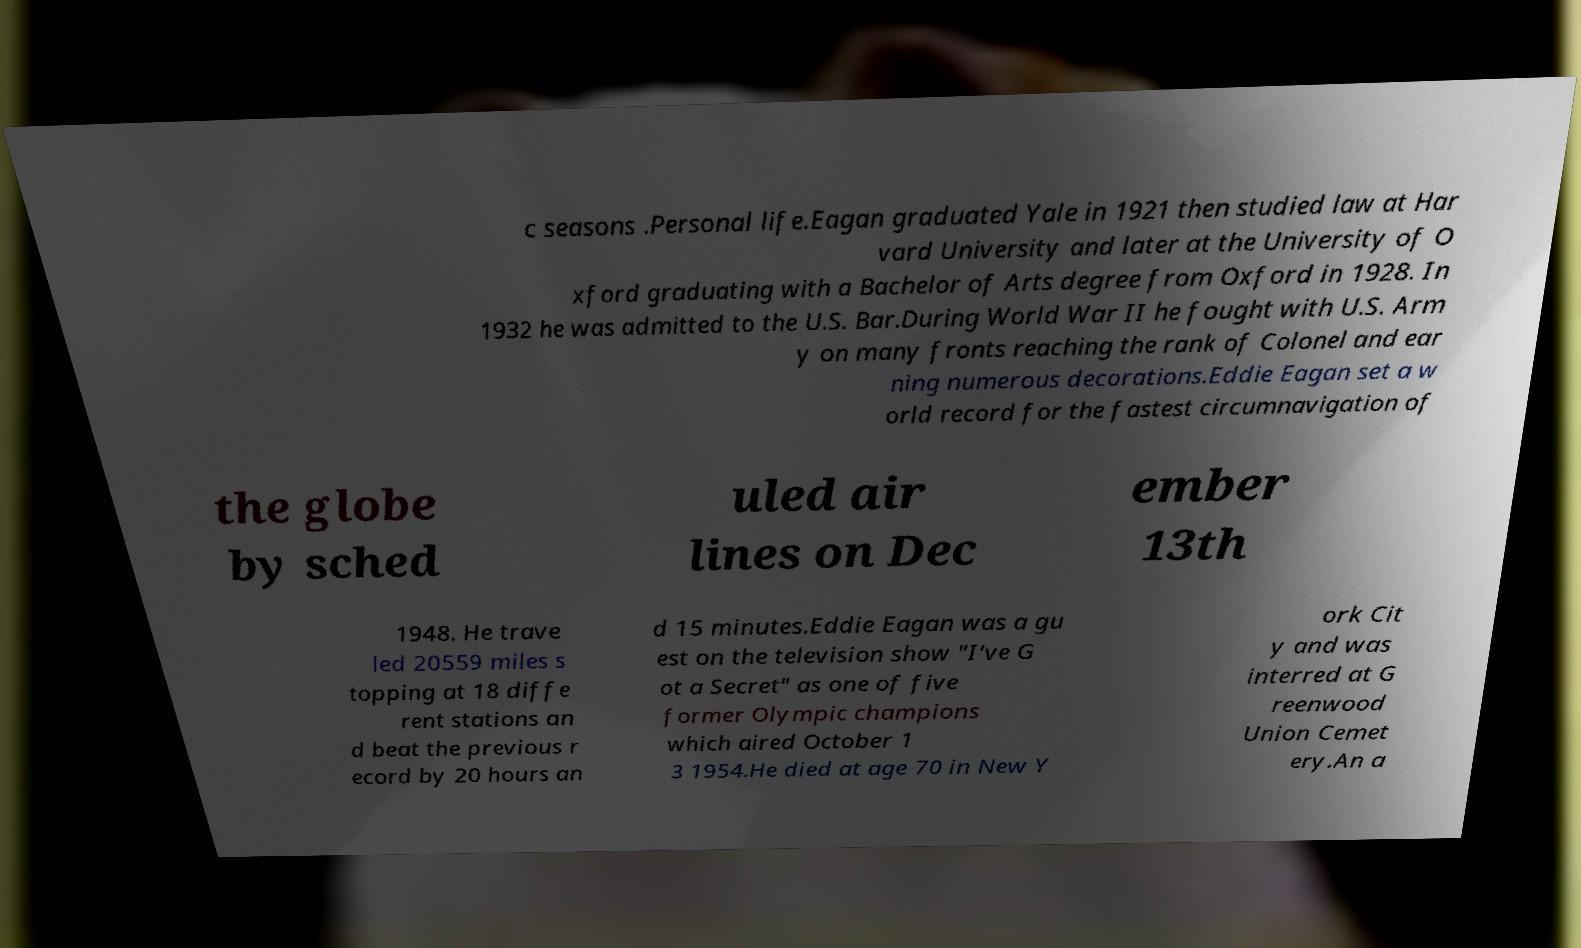What messages or text are displayed in this image? I need them in a readable, typed format. c seasons .Personal life.Eagan graduated Yale in 1921 then studied law at Har vard University and later at the University of O xford graduating with a Bachelor of Arts degree from Oxford in 1928. In 1932 he was admitted to the U.S. Bar.During World War II he fought with U.S. Arm y on many fronts reaching the rank of Colonel and ear ning numerous decorations.Eddie Eagan set a w orld record for the fastest circumnavigation of the globe by sched uled air lines on Dec ember 13th 1948. He trave led 20559 miles s topping at 18 diffe rent stations an d beat the previous r ecord by 20 hours an d 15 minutes.Eddie Eagan was a gu est on the television show "I've G ot a Secret" as one of five former Olympic champions which aired October 1 3 1954.He died at age 70 in New Y ork Cit y and was interred at G reenwood Union Cemet ery.An a 